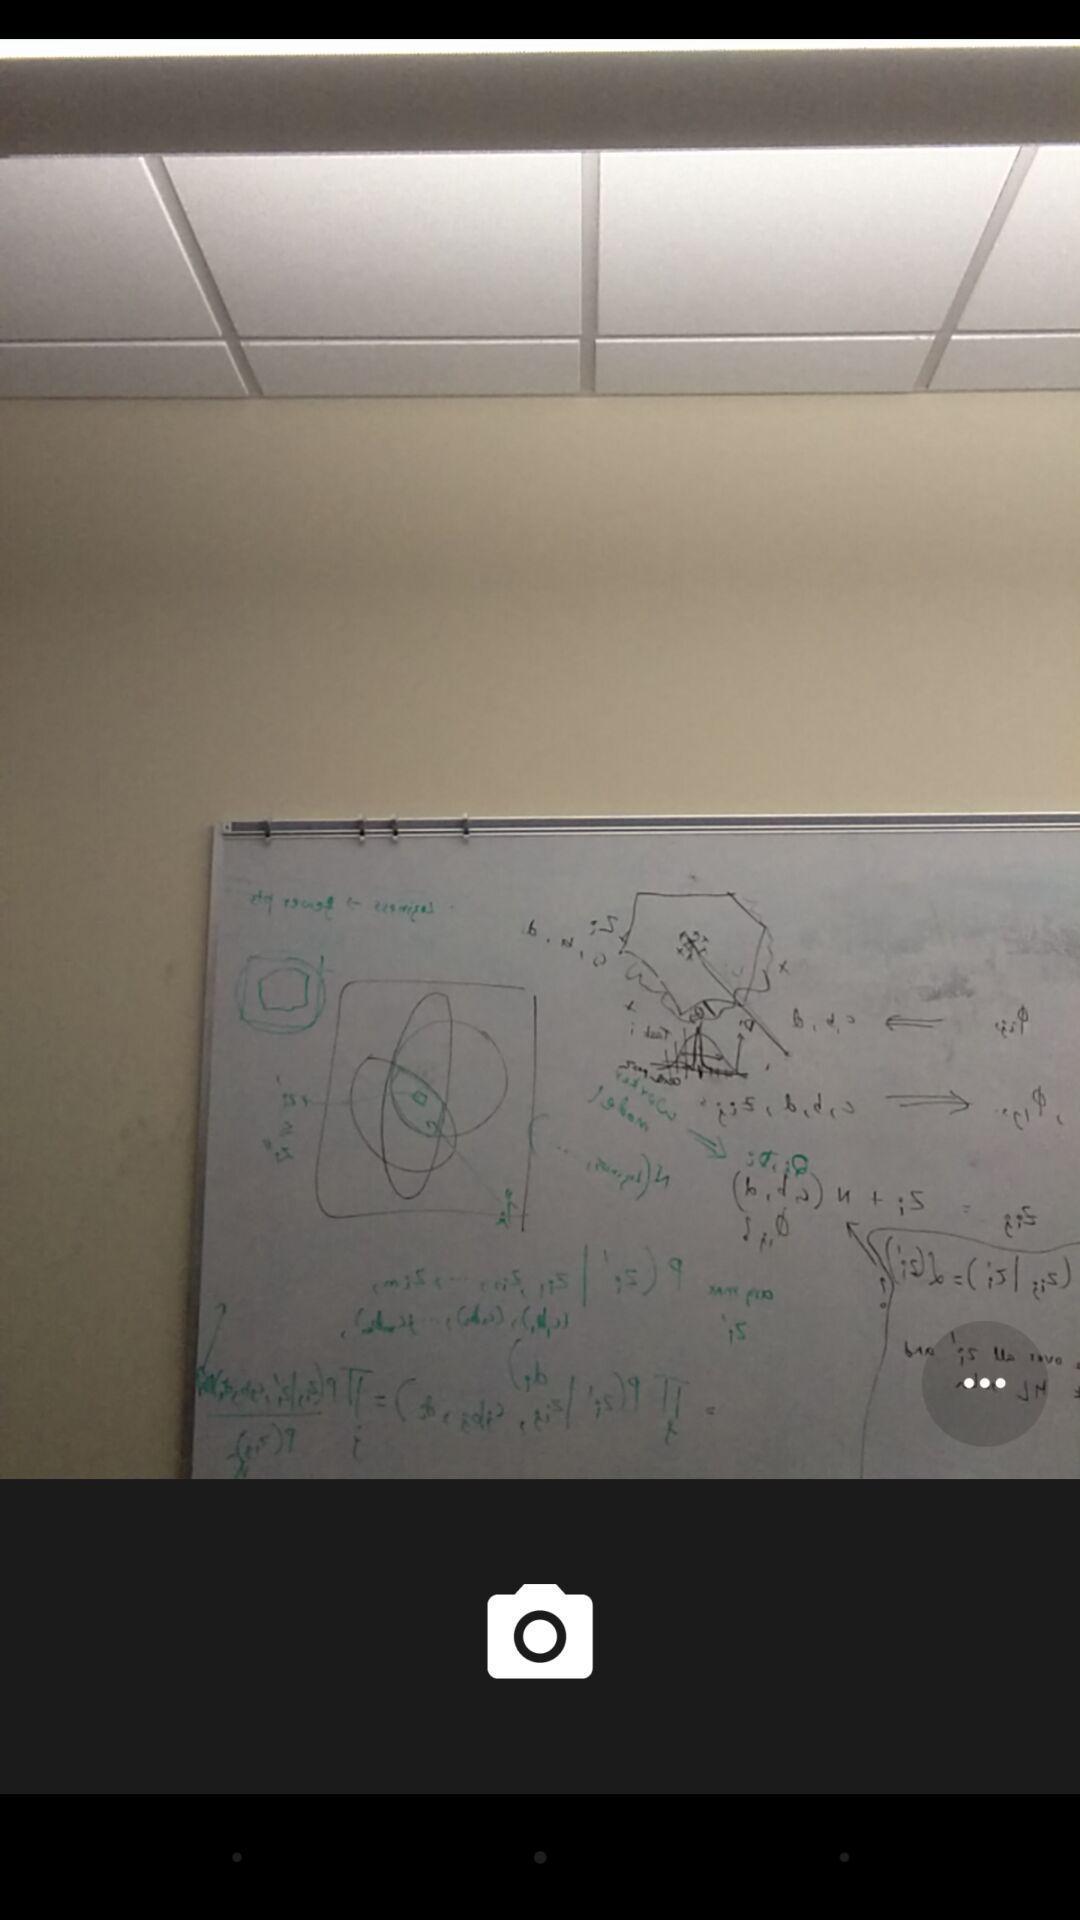Summarize the information in this screenshot. Screen showing a picture of a blackboard. 